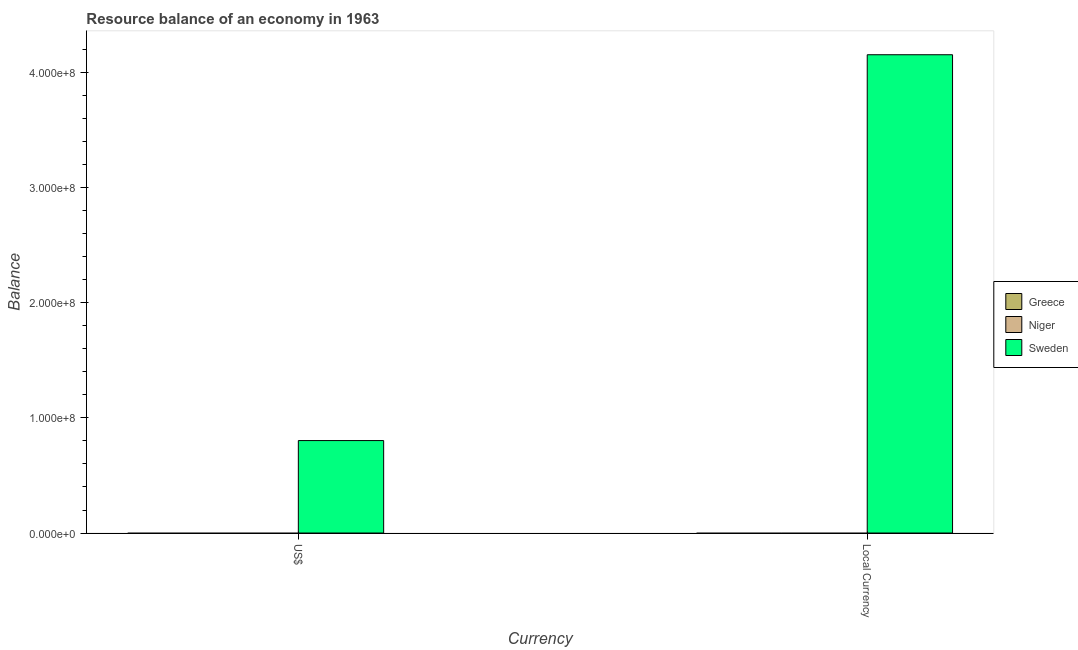What is the label of the 1st group of bars from the left?
Give a very brief answer. US$. What is the resource balance in us$ in Sweden?
Give a very brief answer. 8.03e+07. Across all countries, what is the maximum resource balance in us$?
Your answer should be very brief. 8.03e+07. What is the total resource balance in us$ in the graph?
Your response must be concise. 8.03e+07. What is the difference between the resource balance in us$ in Greece and the resource balance in constant us$ in Niger?
Make the answer very short. 0. What is the average resource balance in constant us$ per country?
Provide a succinct answer. 1.39e+08. What is the difference between the resource balance in us$ and resource balance in constant us$ in Sweden?
Give a very brief answer. -3.35e+08. In how many countries, is the resource balance in us$ greater than 220000000 units?
Give a very brief answer. 0. Are all the bars in the graph horizontal?
Your answer should be very brief. No. Are the values on the major ticks of Y-axis written in scientific E-notation?
Make the answer very short. Yes. Does the graph contain any zero values?
Give a very brief answer. Yes. How many legend labels are there?
Provide a succinct answer. 3. What is the title of the graph?
Your response must be concise. Resource balance of an economy in 1963. What is the label or title of the X-axis?
Provide a short and direct response. Currency. What is the label or title of the Y-axis?
Offer a very short reply. Balance. What is the Balance in Greece in US$?
Provide a short and direct response. 0. What is the Balance in Niger in US$?
Your response must be concise. 0. What is the Balance of Sweden in US$?
Offer a terse response. 8.03e+07. What is the Balance of Greece in Local Currency?
Give a very brief answer. 0. What is the Balance in Niger in Local Currency?
Provide a short and direct response. 0. What is the Balance of Sweden in Local Currency?
Provide a short and direct response. 4.16e+08. Across all Currency, what is the maximum Balance in Sweden?
Your answer should be compact. 4.16e+08. Across all Currency, what is the minimum Balance in Sweden?
Provide a succinct answer. 8.03e+07. What is the total Balance of Greece in the graph?
Offer a terse response. 0. What is the total Balance of Niger in the graph?
Ensure brevity in your answer.  0. What is the total Balance of Sweden in the graph?
Provide a succinct answer. 4.96e+08. What is the difference between the Balance of Sweden in US$ and that in Local Currency?
Your answer should be compact. -3.35e+08. What is the average Balance of Greece per Currency?
Your answer should be very brief. 0. What is the average Balance of Niger per Currency?
Provide a succinct answer. 0. What is the average Balance of Sweden per Currency?
Make the answer very short. 2.48e+08. What is the ratio of the Balance of Sweden in US$ to that in Local Currency?
Offer a terse response. 0.19. What is the difference between the highest and the second highest Balance of Sweden?
Make the answer very short. 3.35e+08. What is the difference between the highest and the lowest Balance in Sweden?
Your answer should be compact. 3.35e+08. 